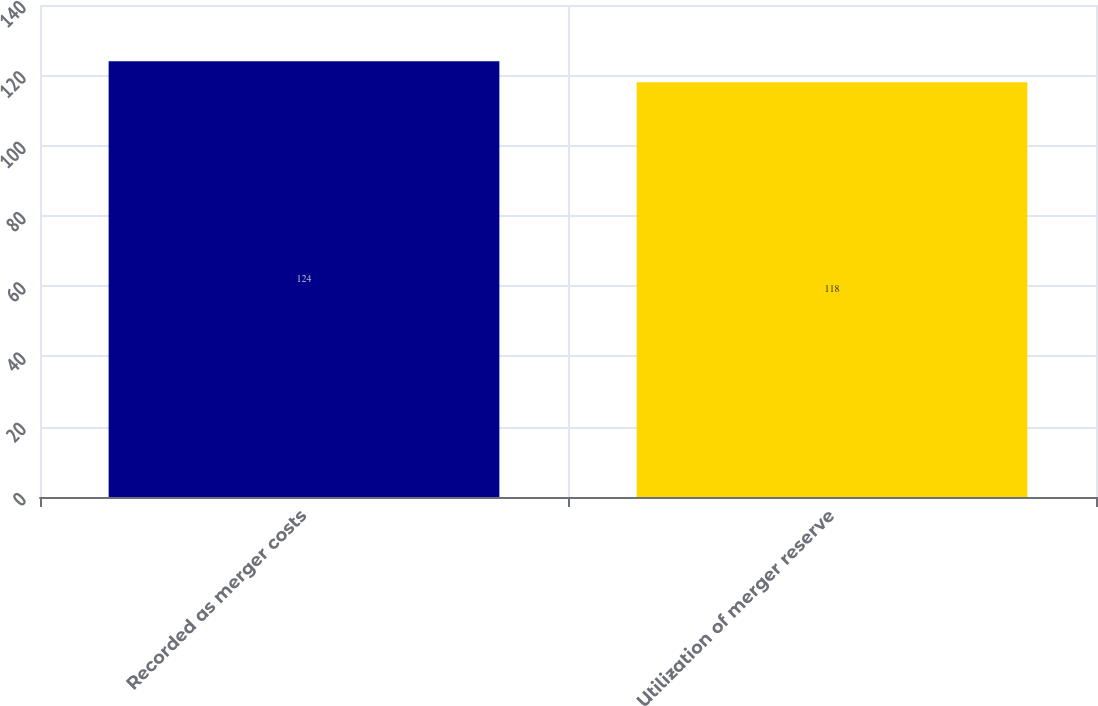<chart> <loc_0><loc_0><loc_500><loc_500><bar_chart><fcel>Recorded as merger costs<fcel>Utilization of merger reserve<nl><fcel>124<fcel>118<nl></chart> 